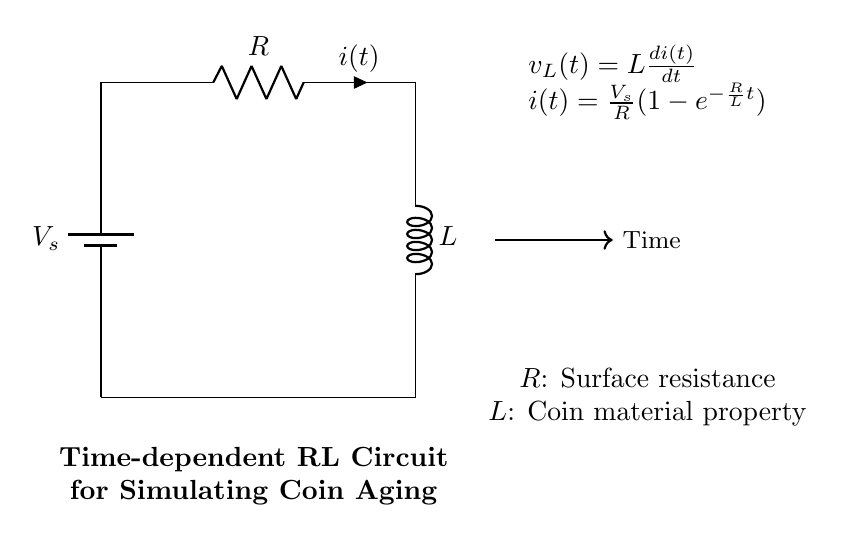What type of circuit is depicted in the diagram? The diagram shows a time-dependent RL circuit, which consists of a resistor and an inductor connected in series. This is evident from the components labeled R and L in the diagram.
Answer: RL circuit What does the symbol "V_s" represent in this circuit? "V_s" indicates the voltage supplied by the battery. It is labeled as the source voltage and is crucial for driving the current in the circuit.
Answer: Source voltage What is the relationship described by the equation "i(t) = V_s/R(1-e^(-Rt/L))"? This equation represents the time-dependent current flowing through the circuit. It shows how the current increases from zero to its maximum value when the switch is closed, as influenced by resistance and inductance.
Answer: Time-dependent current What happens to the voltage across the inductor "v_L(t)" when t approaches infinity? As time approaches infinity, the current stabilizes, causing the voltage across the inductor to approach zero since v_L(t) is proportional to the rate of change of current.
Answer: Approaches zero What is the role of resistance "R" in this RL circuit? The resistor "R" determines how quickly the current reaches its maximum value; greater resistance results in a slower rise in current due to the time constant R/L. This is crucial for simulating the gradual aging of coins.
Answer: Determines current rise time How does the inductor "L" affect the aging process simulation of coins in this circuit? Inductance "L" symbolizes the coin's material properties which influence how the current develops over time. A higher inductance leads to a longer time constant, affecting the rate at which the coin ages.
Answer: Influences time constant 